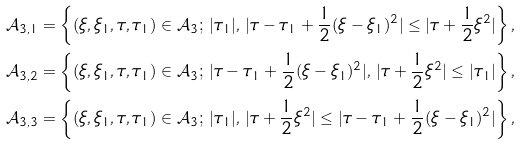<formula> <loc_0><loc_0><loc_500><loc_500>& { \mathcal { A } } _ { 3 , 1 } = \left \{ ( \xi , \xi _ { 1 } , \tau , \tau _ { 1 } ) \in { \mathcal { A } } _ { 3 } ; \, | \tau _ { 1 } | , \, | \tau - \tau _ { 1 } + \frac { 1 } { 2 } ( \xi - \xi _ { 1 } ) ^ { 2 } | \leq | \tau + \frac { 1 } { 2 } \xi ^ { 2 } | \right \} , \\ & { \mathcal { A } } _ { 3 , 2 } = \left \{ ( \xi , \xi _ { 1 } , \tau , \tau _ { 1 } ) \in { \mathcal { A } } _ { 3 } ; \, | \tau - \tau _ { 1 } + \frac { 1 } { 2 } ( \xi - \xi _ { 1 } ) ^ { 2 } | , \, | \tau + \frac { 1 } { 2 } \xi ^ { 2 } | \leq | \tau _ { 1 } | \right \} , \\ & { \mathcal { A } } _ { 3 , 3 } = \left \{ ( \xi , \xi _ { 1 } , \tau , \tau _ { 1 } ) \in { \mathcal { A } } _ { 3 } ; \, | \tau _ { 1 } | , \, | \tau + \frac { 1 } { 2 } \xi ^ { 2 } | \leq | \tau - \tau _ { 1 } + \frac { 1 } { 2 } ( \xi - \xi _ { 1 } ) ^ { 2 } | \right \} ,</formula> 